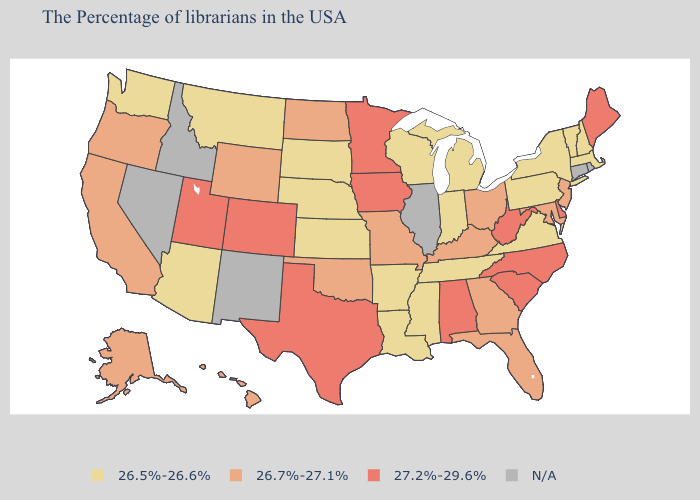Among the states that border Kentucky , which have the lowest value?
Write a very short answer. Virginia, Indiana, Tennessee. Name the states that have a value in the range 27.2%-29.6%?
Short answer required. Maine, Delaware, North Carolina, South Carolina, West Virginia, Alabama, Minnesota, Iowa, Texas, Colorado, Utah. Among the states that border Delaware , which have the lowest value?
Quick response, please. Pennsylvania. Which states hav the highest value in the MidWest?
Write a very short answer. Minnesota, Iowa. Does Oregon have the highest value in the West?
Short answer required. No. Name the states that have a value in the range 26.7%-27.1%?
Quick response, please. New Jersey, Maryland, Ohio, Florida, Georgia, Kentucky, Missouri, Oklahoma, North Dakota, Wyoming, California, Oregon, Alaska, Hawaii. What is the lowest value in states that border Utah?
Quick response, please. 26.5%-26.6%. What is the highest value in the MidWest ?
Quick response, please. 27.2%-29.6%. Name the states that have a value in the range 26.5%-26.6%?
Short answer required. Massachusetts, New Hampshire, Vermont, New York, Pennsylvania, Virginia, Michigan, Indiana, Tennessee, Wisconsin, Mississippi, Louisiana, Arkansas, Kansas, Nebraska, South Dakota, Montana, Arizona, Washington. What is the highest value in the West ?
Write a very short answer. 27.2%-29.6%. What is the value of Idaho?
Be succinct. N/A. Name the states that have a value in the range N/A?
Short answer required. Rhode Island, Connecticut, Illinois, New Mexico, Idaho, Nevada. What is the value of Oregon?
Be succinct. 26.7%-27.1%. Does the first symbol in the legend represent the smallest category?
Be succinct. Yes. What is the value of Montana?
Give a very brief answer. 26.5%-26.6%. 